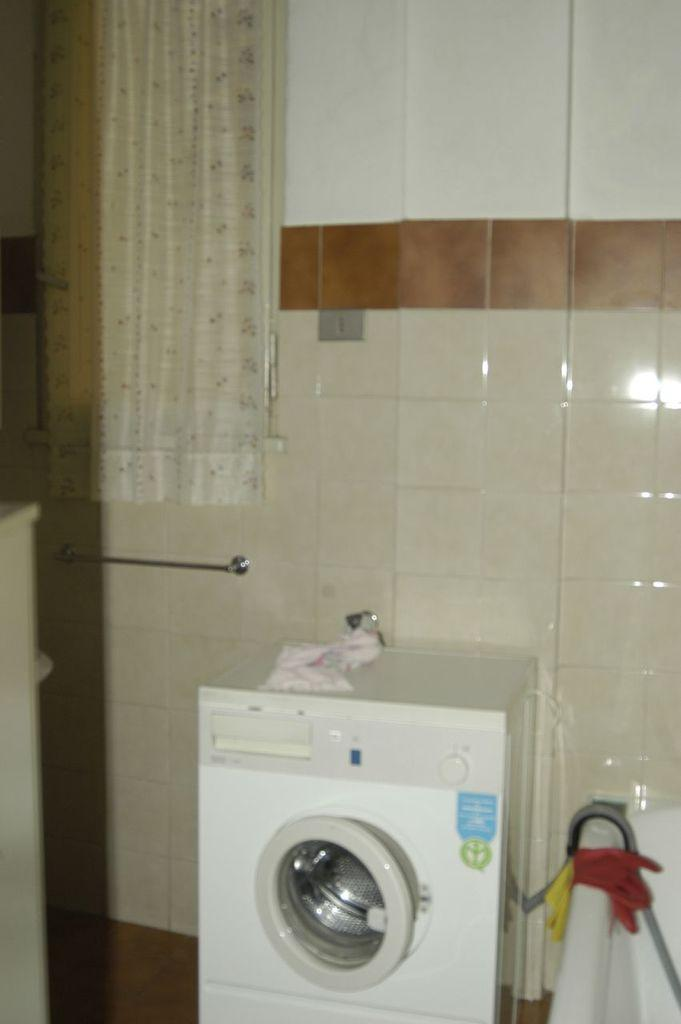What appliance is located in the middle of the image? There is a washing machine in the middle of the image. What can be seen on the right side of the image? There is a sink on the right side of the image. What is visible in the background of the image? There is a curtain, tiles, and a wall in the background of the image. What is the size of the nail that is holding the curtain in the image? There is no nail visible in the image; the curtain is held by a rod or other support mechanism. How does the washing machine cry in the image? Washing machines do not have the ability to cry; they are inanimate objects. 